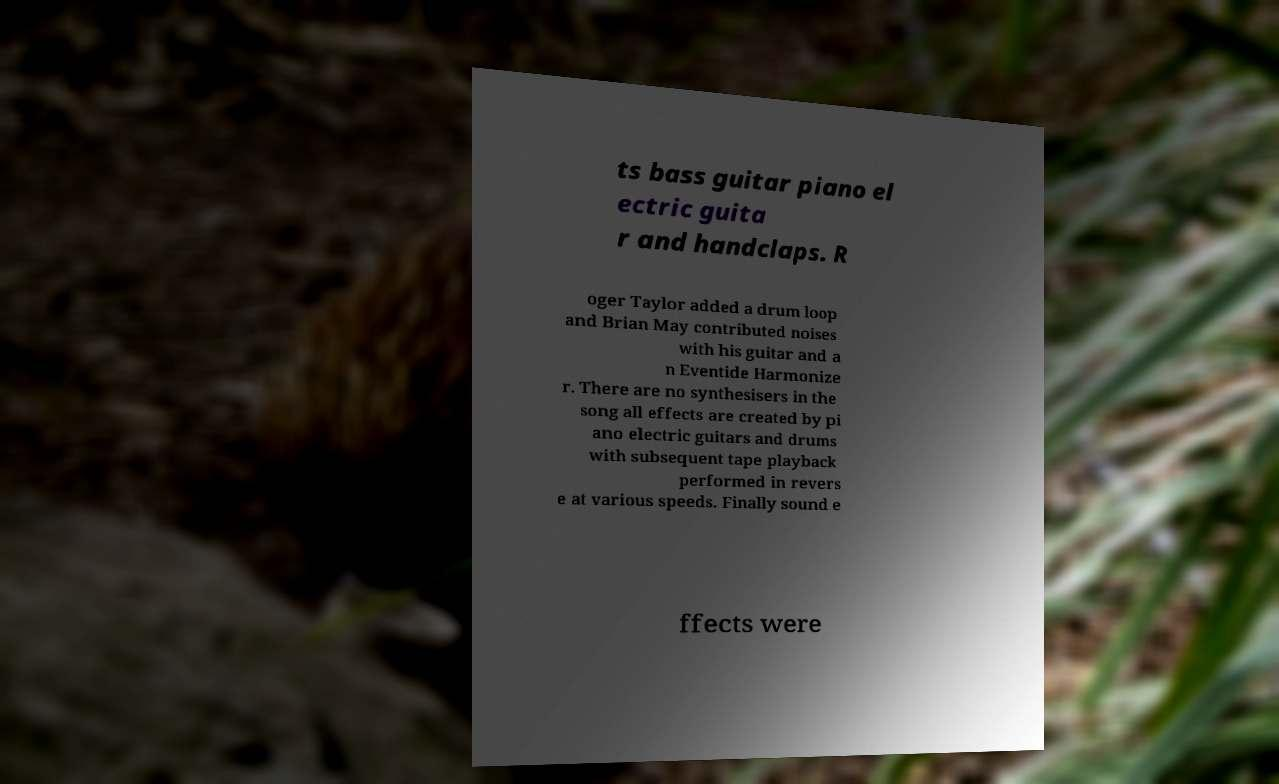Could you assist in decoding the text presented in this image and type it out clearly? ts bass guitar piano el ectric guita r and handclaps. R oger Taylor added a drum loop and Brian May contributed noises with his guitar and a n Eventide Harmonize r. There are no synthesisers in the song all effects are created by pi ano electric guitars and drums with subsequent tape playback performed in revers e at various speeds. Finally sound e ffects were 